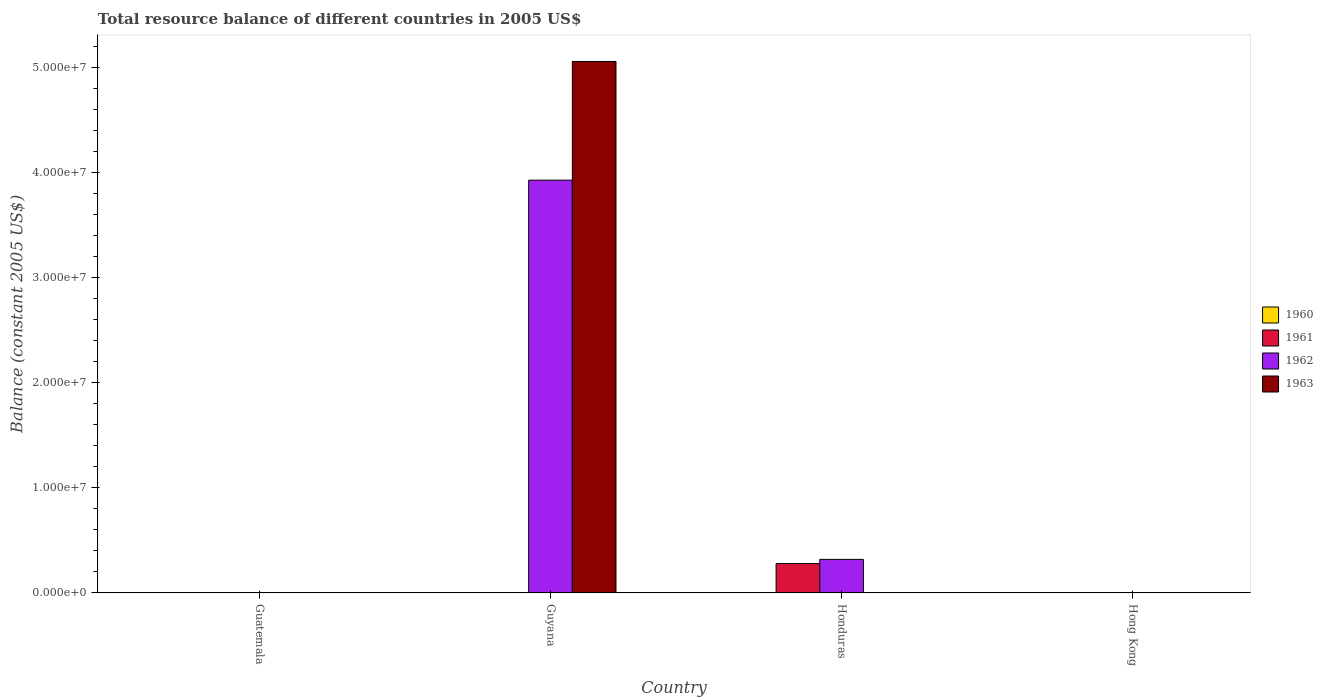How many different coloured bars are there?
Offer a very short reply. 3. How many bars are there on the 2nd tick from the left?
Provide a succinct answer. 2. How many bars are there on the 1st tick from the right?
Offer a terse response. 0. What is the label of the 4th group of bars from the left?
Provide a succinct answer. Hong Kong. What is the total resource balance in 1961 in Guyana?
Keep it short and to the point. 0. Across all countries, what is the maximum total resource balance in 1961?
Your response must be concise. 2.80e+06. In which country was the total resource balance in 1963 maximum?
Make the answer very short. Guyana. What is the total total resource balance in 1961 in the graph?
Offer a very short reply. 2.80e+06. What is the difference between the total resource balance in 1962 in Guyana and the total resource balance in 1963 in Honduras?
Your answer should be very brief. 3.93e+07. In how many countries, is the total resource balance in 1963 greater than 14000000 US$?
Your response must be concise. 1. What is the difference between the highest and the lowest total resource balance in 1962?
Offer a very short reply. 3.93e+07. How many bars are there?
Give a very brief answer. 4. How many countries are there in the graph?
Offer a terse response. 4. What is the difference between two consecutive major ticks on the Y-axis?
Your answer should be compact. 1.00e+07. Are the values on the major ticks of Y-axis written in scientific E-notation?
Your response must be concise. Yes. Does the graph contain grids?
Provide a short and direct response. No. Where does the legend appear in the graph?
Your answer should be compact. Center right. What is the title of the graph?
Your response must be concise. Total resource balance of different countries in 2005 US$. Does "1999" appear as one of the legend labels in the graph?
Keep it short and to the point. No. What is the label or title of the X-axis?
Provide a short and direct response. Country. What is the label or title of the Y-axis?
Offer a very short reply. Balance (constant 2005 US$). What is the Balance (constant 2005 US$) in 1960 in Guatemala?
Offer a very short reply. 0. What is the Balance (constant 2005 US$) in 1961 in Guatemala?
Your response must be concise. 0. What is the Balance (constant 2005 US$) of 1962 in Guatemala?
Provide a succinct answer. 0. What is the Balance (constant 2005 US$) of 1960 in Guyana?
Give a very brief answer. 0. What is the Balance (constant 2005 US$) in 1961 in Guyana?
Offer a terse response. 0. What is the Balance (constant 2005 US$) of 1962 in Guyana?
Your answer should be very brief. 3.93e+07. What is the Balance (constant 2005 US$) of 1963 in Guyana?
Offer a terse response. 5.06e+07. What is the Balance (constant 2005 US$) of 1961 in Honduras?
Your answer should be compact. 2.80e+06. What is the Balance (constant 2005 US$) of 1962 in Honduras?
Your answer should be very brief. 3.20e+06. What is the Balance (constant 2005 US$) of 1960 in Hong Kong?
Provide a short and direct response. 0. Across all countries, what is the maximum Balance (constant 2005 US$) in 1961?
Provide a succinct answer. 2.80e+06. Across all countries, what is the maximum Balance (constant 2005 US$) in 1962?
Keep it short and to the point. 3.93e+07. Across all countries, what is the maximum Balance (constant 2005 US$) of 1963?
Offer a very short reply. 5.06e+07. What is the total Balance (constant 2005 US$) in 1961 in the graph?
Your answer should be compact. 2.80e+06. What is the total Balance (constant 2005 US$) of 1962 in the graph?
Your answer should be very brief. 4.25e+07. What is the total Balance (constant 2005 US$) in 1963 in the graph?
Offer a very short reply. 5.06e+07. What is the difference between the Balance (constant 2005 US$) in 1962 in Guyana and that in Honduras?
Keep it short and to the point. 3.61e+07. What is the average Balance (constant 2005 US$) of 1961 per country?
Make the answer very short. 7.00e+05. What is the average Balance (constant 2005 US$) of 1962 per country?
Your answer should be compact. 1.06e+07. What is the average Balance (constant 2005 US$) of 1963 per country?
Your response must be concise. 1.26e+07. What is the difference between the Balance (constant 2005 US$) of 1962 and Balance (constant 2005 US$) of 1963 in Guyana?
Keep it short and to the point. -1.13e+07. What is the difference between the Balance (constant 2005 US$) in 1961 and Balance (constant 2005 US$) in 1962 in Honduras?
Provide a succinct answer. -4.00e+05. What is the ratio of the Balance (constant 2005 US$) in 1962 in Guyana to that in Honduras?
Offer a terse response. 12.28. What is the difference between the highest and the lowest Balance (constant 2005 US$) in 1961?
Offer a terse response. 2.80e+06. What is the difference between the highest and the lowest Balance (constant 2005 US$) in 1962?
Offer a terse response. 3.93e+07. What is the difference between the highest and the lowest Balance (constant 2005 US$) of 1963?
Your response must be concise. 5.06e+07. 